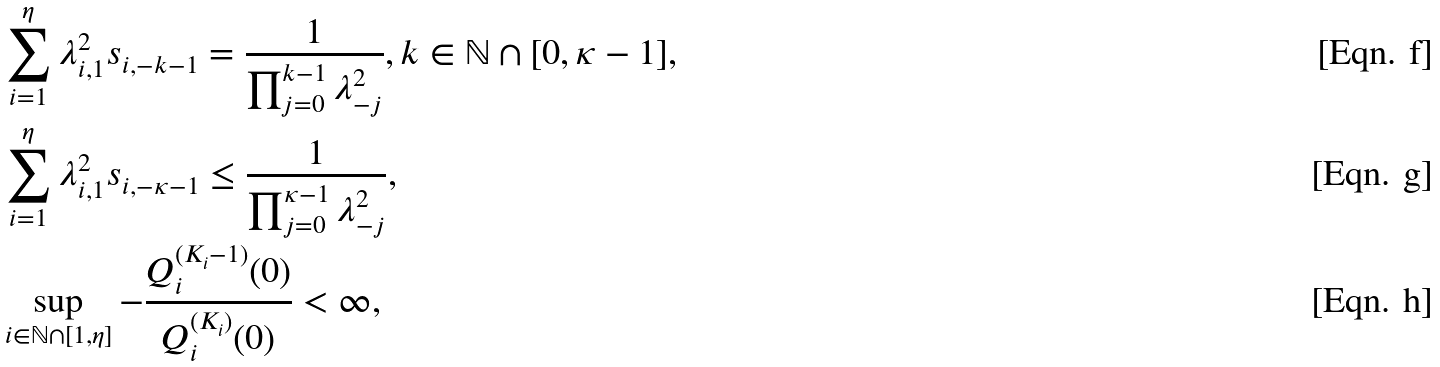Convert formula to latex. <formula><loc_0><loc_0><loc_500><loc_500>& \sum _ { i = 1 } ^ { \eta } \lambda _ { i , 1 } ^ { 2 } s _ { i , - k - 1 } = \frac { 1 } { \prod _ { j = 0 } ^ { k - 1 } \lambda _ { - j } ^ { 2 } } , k \in \mathbb { N } \cap [ 0 , \kappa - 1 ] , \\ & \sum _ { i = 1 } ^ { \eta } \lambda _ { i , 1 } ^ { 2 } s _ { i , - \kappa - 1 } \leq \frac { 1 } { \prod _ { j = 0 } ^ { \kappa - 1 } \lambda _ { - j } ^ { 2 } } , \\ & \sup _ { i \in \mathbb { N } \cap [ 1 , \eta ] } - \frac { Q _ { i } ^ { ( K _ { i } - 1 ) } ( 0 ) } { Q _ { i } ^ { ( K _ { i } ) } ( 0 ) } < \infty ,</formula> 